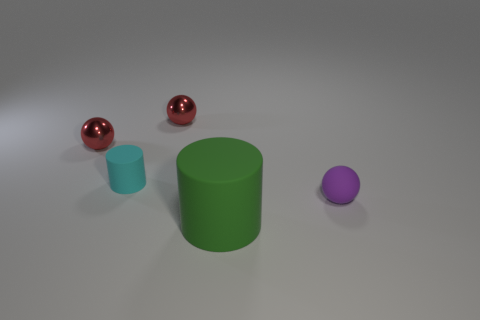How many big matte cylinders are right of the tiny purple object?
Make the answer very short. 0. Are there more big metallic objects than tiny matte objects?
Offer a terse response. No. What shape is the large matte object right of the cylinder that is behind the large cylinder?
Your response must be concise. Cylinder. Is the small rubber cylinder the same color as the large object?
Provide a succinct answer. No. Is the number of small red spheres that are behind the purple thing greater than the number of big red objects?
Provide a succinct answer. Yes. How many spheres are on the left side of the matte cylinder in front of the small purple object?
Give a very brief answer. 2. Do the thing that is in front of the small purple rubber thing and the cylinder that is left of the big green rubber object have the same material?
Give a very brief answer. Yes. How many large green objects are the same shape as the purple thing?
Keep it short and to the point. 0. Are the small cyan thing and the small object on the right side of the green cylinder made of the same material?
Provide a short and direct response. Yes. There is a purple thing that is the same size as the cyan cylinder; what is it made of?
Keep it short and to the point. Rubber. 